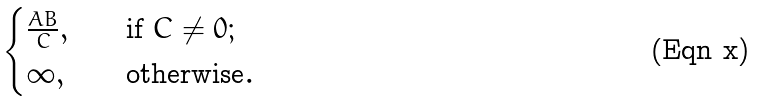Convert formula to latex. <formula><loc_0><loc_0><loc_500><loc_500>\begin{cases} \frac { A B } { C } , & \quad \text {if } C \neq 0 ; \\ \infty , & \quad \text {otherwise} . \end{cases}</formula> 